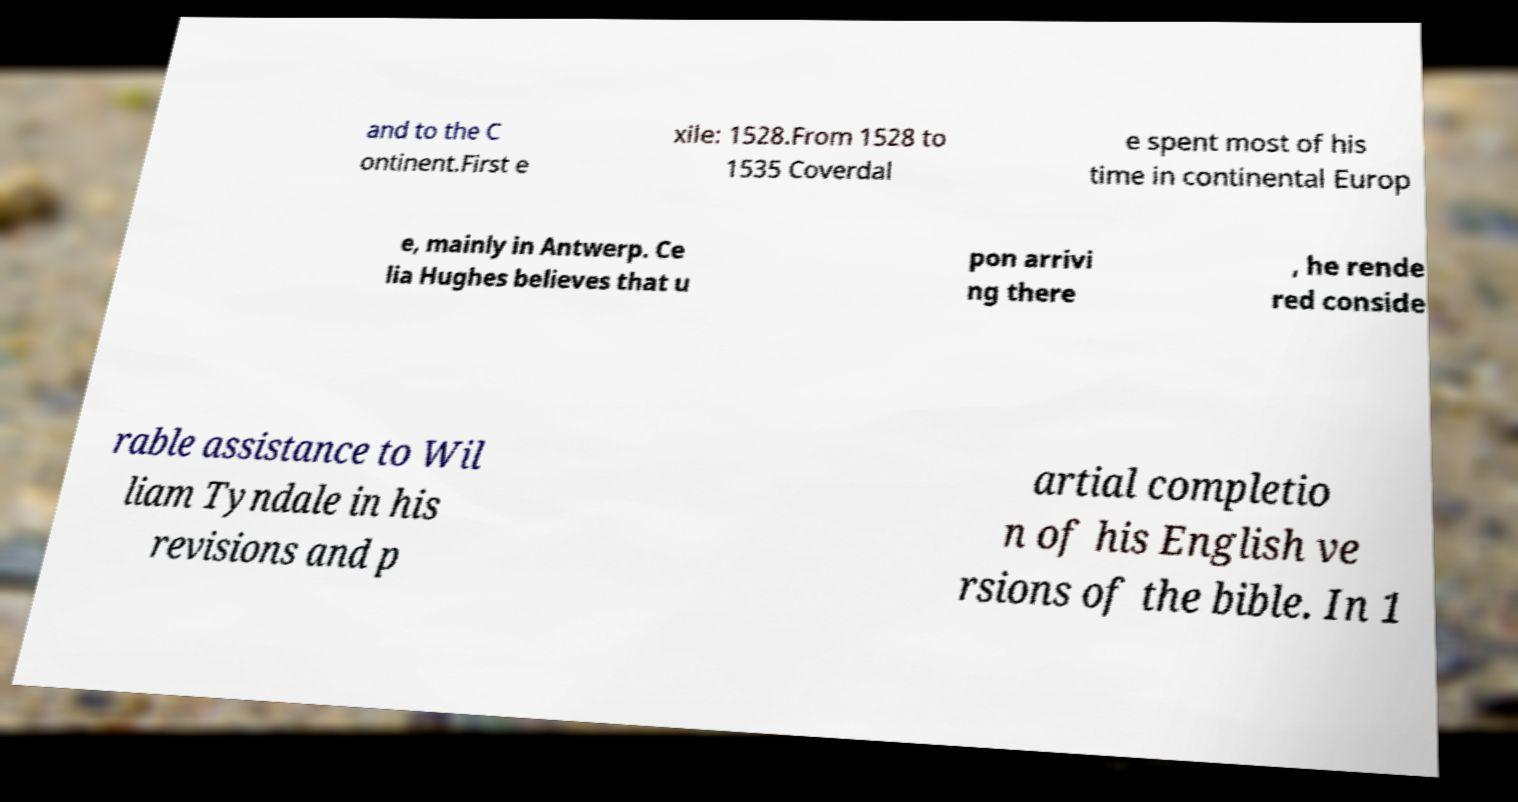Please read and relay the text visible in this image. What does it say? and to the C ontinent.First e xile: 1528.From 1528 to 1535 Coverdal e spent most of his time in continental Europ e, mainly in Antwerp. Ce lia Hughes believes that u pon arrivi ng there , he rende red conside rable assistance to Wil liam Tyndale in his revisions and p artial completio n of his English ve rsions of the bible. In 1 